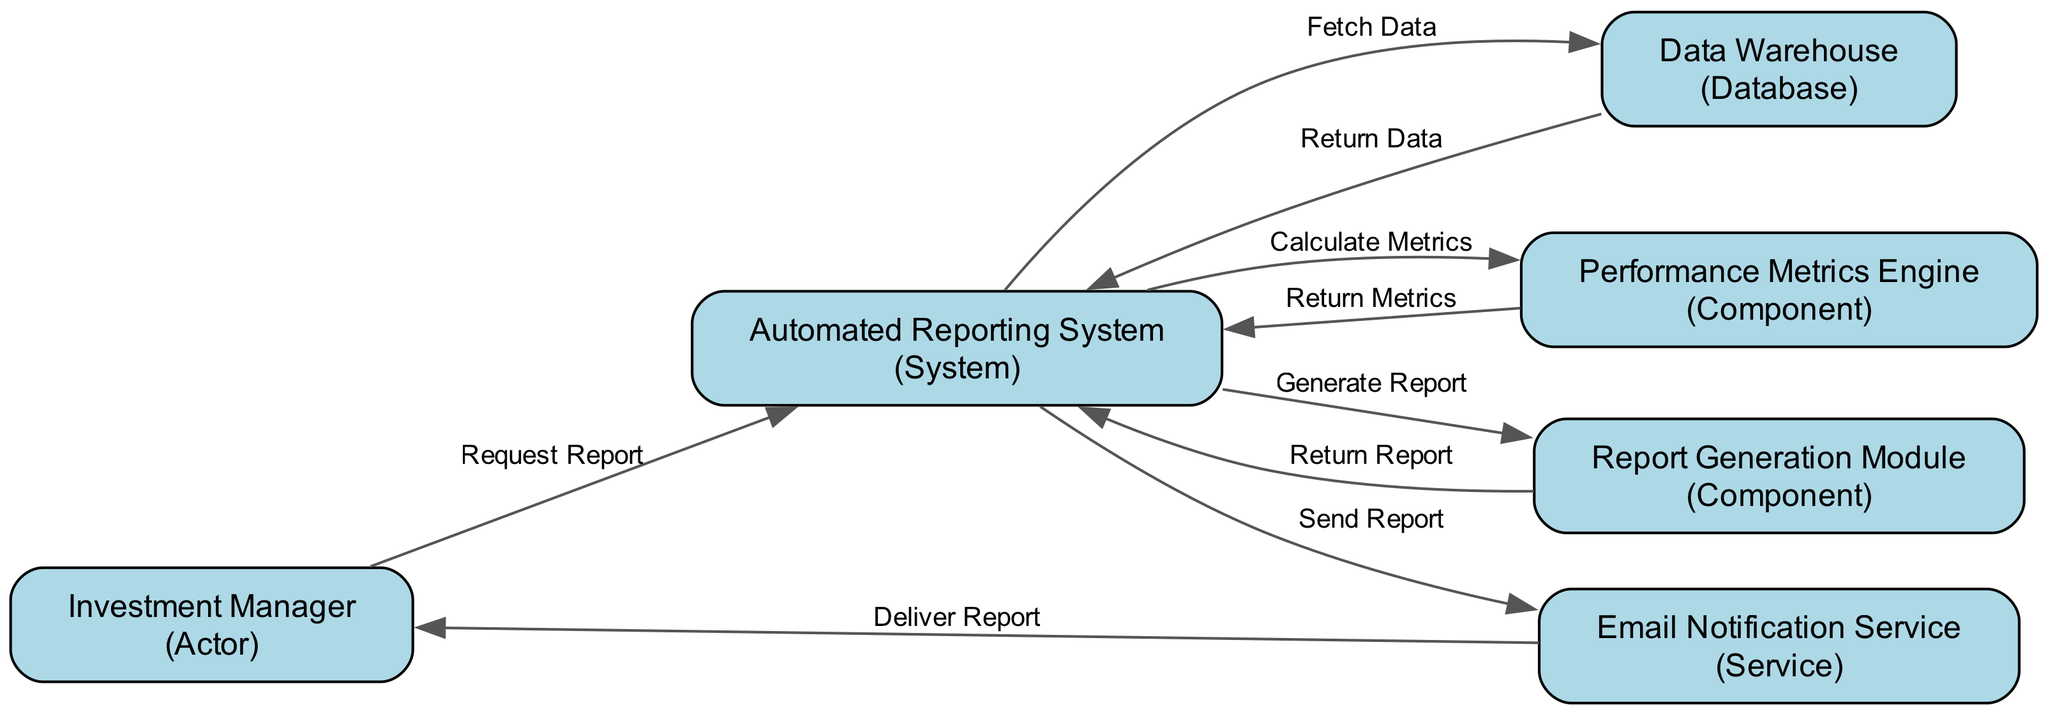What is the first action taken by the Investment Manager? The diagram indicates that the first action taken by the Investment Manager is to request a report from the Automated Reporting System. This is the initial edge shown leading from the Investment Manager to the Automated Reporting System.
Answer: Request Report How many components are involved in the report generation process? Analyzing the diagram, there are three components involved in the report generation process: the Performance Metrics Engine, the Report Generation Module, and the Email Notification Service. Each has specific roles in compiling and delivering the reports.
Answer: Three Which component calculates the metrics? The diagram shows that the component responsible for calculating the metrics is the Performance Metrics Engine, as indicated by the edge connecting the Automated Reporting System to this component with the action 'Calculate Metrics'.
Answer: Performance Metrics Engine What does the Automated Reporting System do after receiving data from the Data Warehouse? After the Automated Reporting System receives data from the Data Warehouse, it forwards this data to the Performance Metrics Engine to calculate metrics, as indicated by the sequence of actions represented by the arrows.
Answer: Calculate Metrics What is the final action in the sequence diagram? The last action in the sequence diagram is the delivery of the report via the Email Notification Service to the Investment Manager, depicted by the final edge leading from the Email Notification Service to the Investment Manager.
Answer: Deliver Report Which entity sends out the performance reports? According to the diagram, the Email Notification Service is the entity that sends out the performance reports to the Investment Manager after the report is generated. This is shown by the connection from the Automated Reporting System to this service.
Answer: Email Notification Service What is the relationship between the Automated Reporting System and Data Warehouse? The relationship depicted is a data fetching action, where the Automated Reporting System first sends a request to the Data Warehouse to fetch data, and then receives the data back, representing a two-way interaction.
Answer: Fetch Data, Return Data How many edges are there in the diagram? Counting the connections (edges) between the entities, there are a total of eight edges present in the sequence diagram, representing different actions taken during the report generation process.
Answer: Eight 